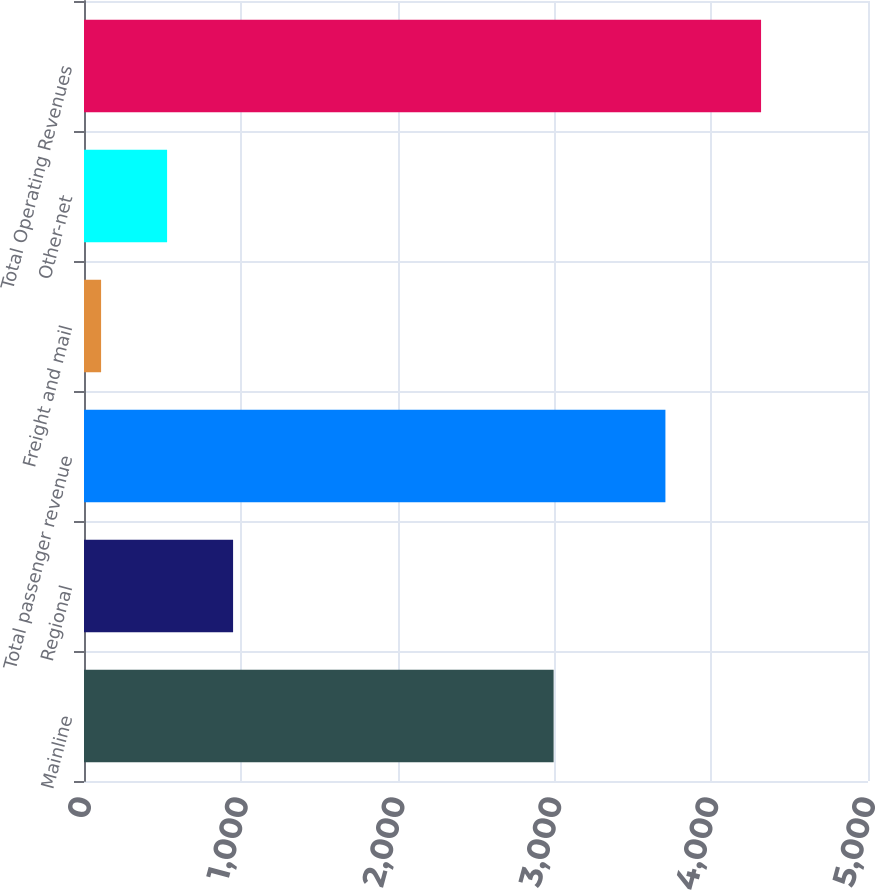<chart> <loc_0><loc_0><loc_500><loc_500><bar_chart><fcel>Mainline<fcel>Regional<fcel>Total passenger revenue<fcel>Freight and mail<fcel>Other-net<fcel>Total Operating Revenues<nl><fcel>2995<fcel>950.8<fcel>3708<fcel>109<fcel>529.9<fcel>4318<nl></chart> 